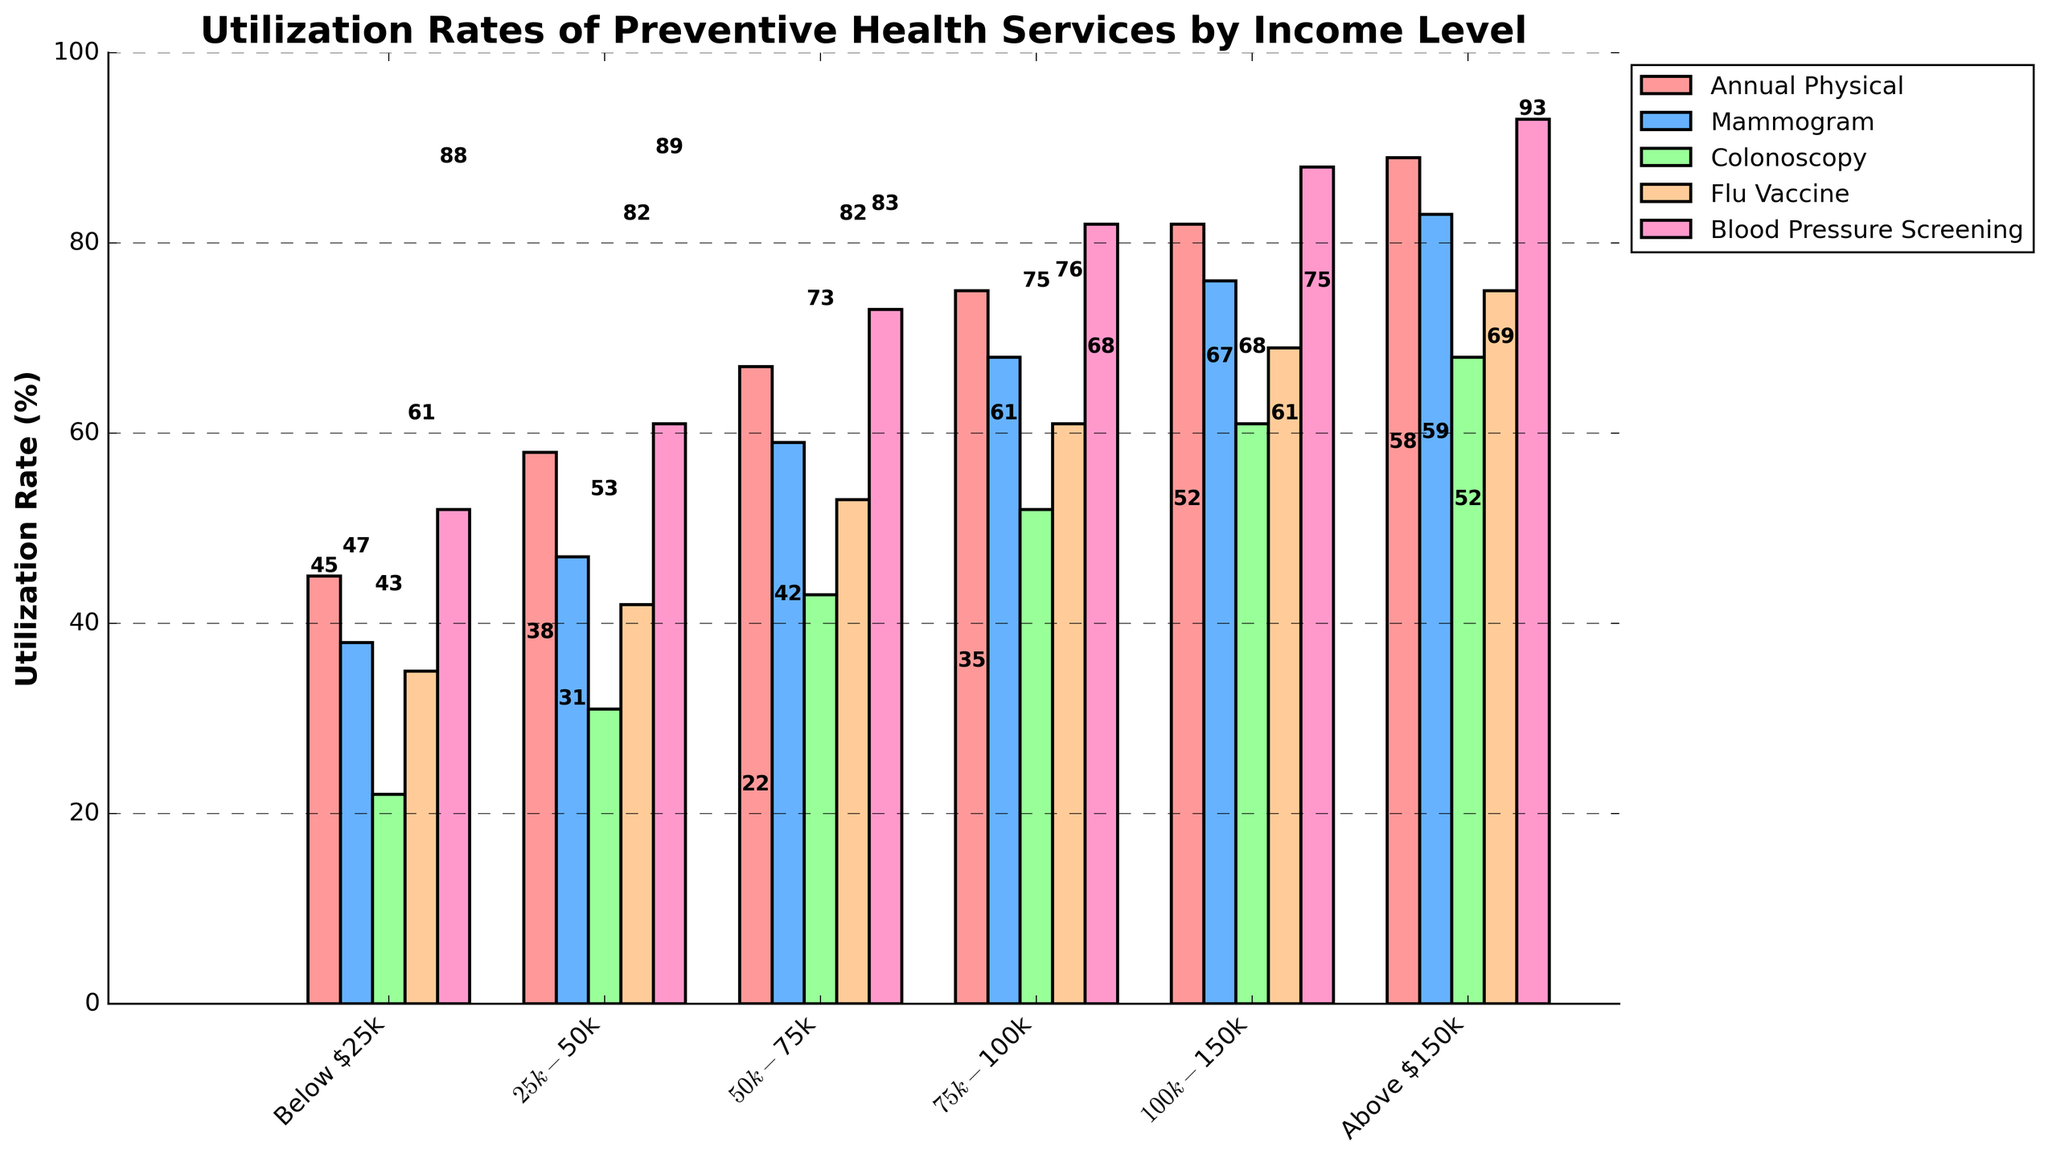What income level has the highest utilization rate for annual physicals? The highest bar for the annual physicals category represents the income level above $150k, so they have the highest utilization rate.
Answer: Above $150k Compare the utilization rates of mammograms for the $50k-$75k and $75k-$100k income levels. Which one is higher and by how much? The bar for mammograms at $75k-$100k is higher at 68%, compared to $50k-$75k at 59%. The difference is 68 - 59 = 9%.
Answer: $75k-$100k by 9% What is the average utilization rate of flu vaccines for income levels below $50k? The flu vaccine rates for Below $25k and $25k-$50k are 35% and 42%. The average is (35 + 42) / 2 = 38.5%.
Answer: 38.5% Is the utilization rate of blood pressure screenings for income levels below $25k greater than the utilization rate of colonoscopies for income levels $75k-$100k? The blood pressure screening rate for below $25k is 52%, and the colonoscopy rate for $75k-$100k is 52%. 52% is equal to 52%.
Answer: Equal What is the utilization rate difference between annual physicals and colonoscopies for income levels $100k-$150k? For the $100k-$150k income level, the annual physical rate is 82% and colonoscopy rate is 61%. The difference is 82 - 61 = 21%.
Answer: 21% Which income level has the least utilization rate for mammograms, and what is that rate? The bar for mammograms with the lowest height corresponds to Below $25k, which has a rate of 38%.
Answer: Below $25k, 38% How much does the utilization rate for flu vaccines increase from the $25k-$50k to the $75k-$100k income levels? The rates for flu vaccines are 42% at $25k-$50k and 61% at $75k-$100k. The increase is 61 - 42 = 19%.
Answer: 19% Compare the utilization rates for annual physicals and blood pressure screenings at the income level $50k-$75k. Which service has a higher rate and by how much? For $50k-$75k, annual physicals are at 67%, and blood pressure screenings are at 73%. The difference is 73 - 67 = 6%.
Answer: Blood pressure screenings by 6% What is the combined utilization rate for mammograms and flu vaccines at the income level above $150k? The mammogram rate is 83%, and flu vaccine rate is 75%. The combined rate is 83 + 75 = 158%.
Answer: 158% What's the overall trend in utilization rates for preventive health services as income levels increase? As income levels increase, the utilization rates for all services generally rise, indicating higher income levels are associated with more frequent use of preventive health services.
Answer: Increase 